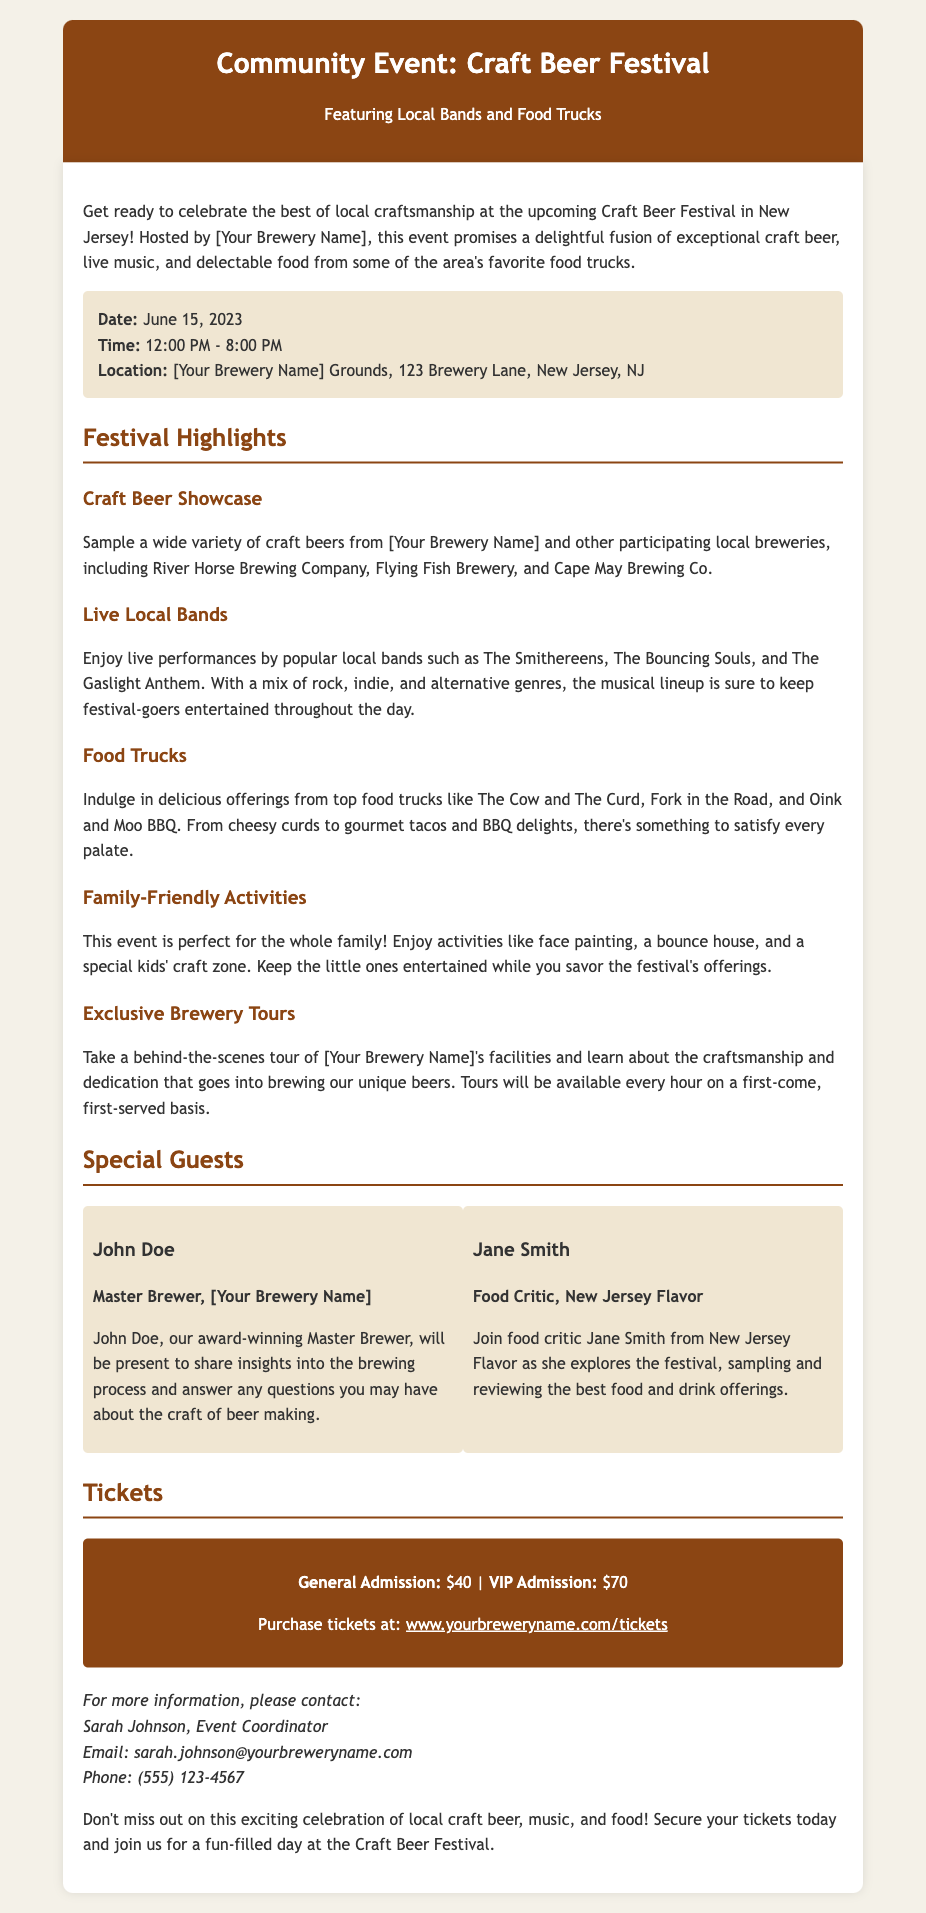What is the date of the Craft Beer Festival? The document explicitly states the date for the event is June 15, 2023.
Answer: June 15, 2023 What are the hours for the festival? The festival is scheduled to take place from 12:00 PM to 8:00 PM as mentioned in the event details.
Answer: 12:00 PM - 8:00 PM Who is the Master Brewer representing your brewery? John Doe is identified as the Master Brewer in the special guests section of the document.
Answer: John Doe What type of activities are available for families? The document outlines family-friendly activities including face painting and a bounce house.
Answer: Face painting, a bounce house What is the price of VIP admission? The ticket details specify that VIP admission costs $70.
Answer: $70 How frequently will the exclusive brewery tours happen? It states that the brewery tours will be available every hour, which indicates the frequency of the tours.
Answer: Every hour Which food truck is mentioned for gourmet tacos? The document mentions Fork in the Road as the food truck offering gourmet tacos.
Answer: Fork in the Road What type of music genres will be featured at the festival? The festival features a mix of rock, indie, and alternative genres according to the live bands section.
Answer: Rock, indie, and alternative 